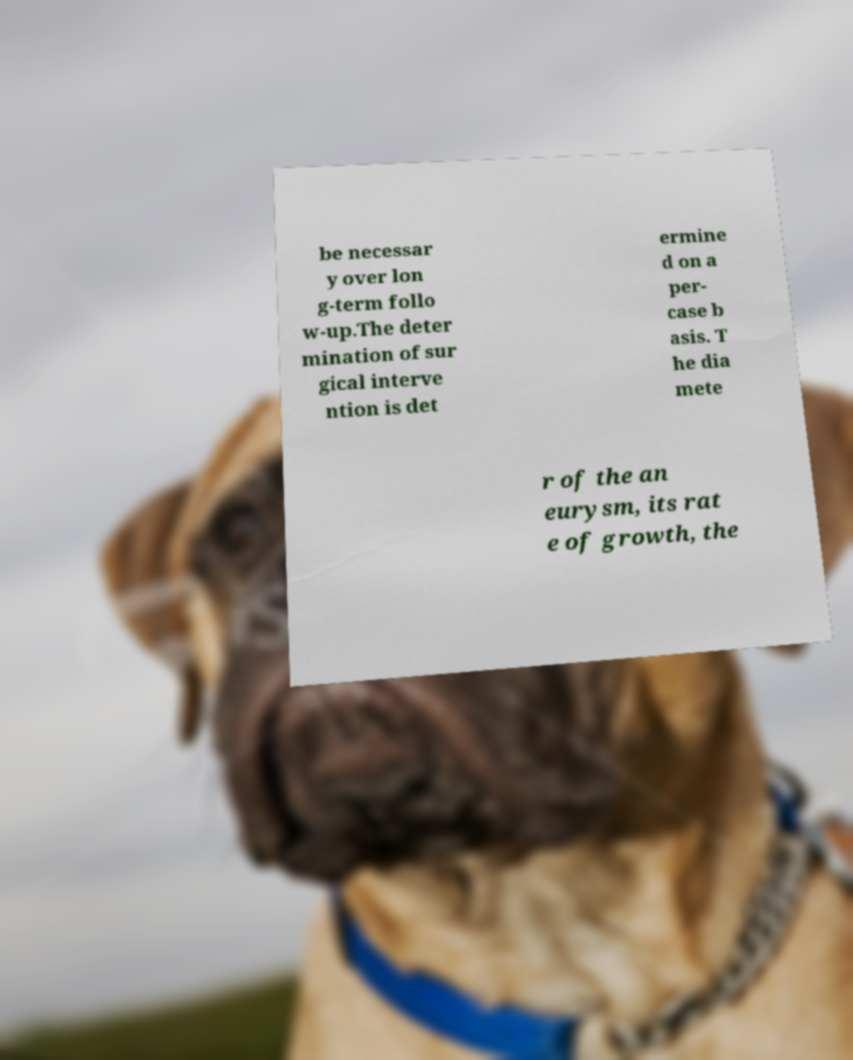Could you extract and type out the text from this image? be necessar y over lon g-term follo w-up.The deter mination of sur gical interve ntion is det ermine d on a per- case b asis. T he dia mete r of the an eurysm, its rat e of growth, the 